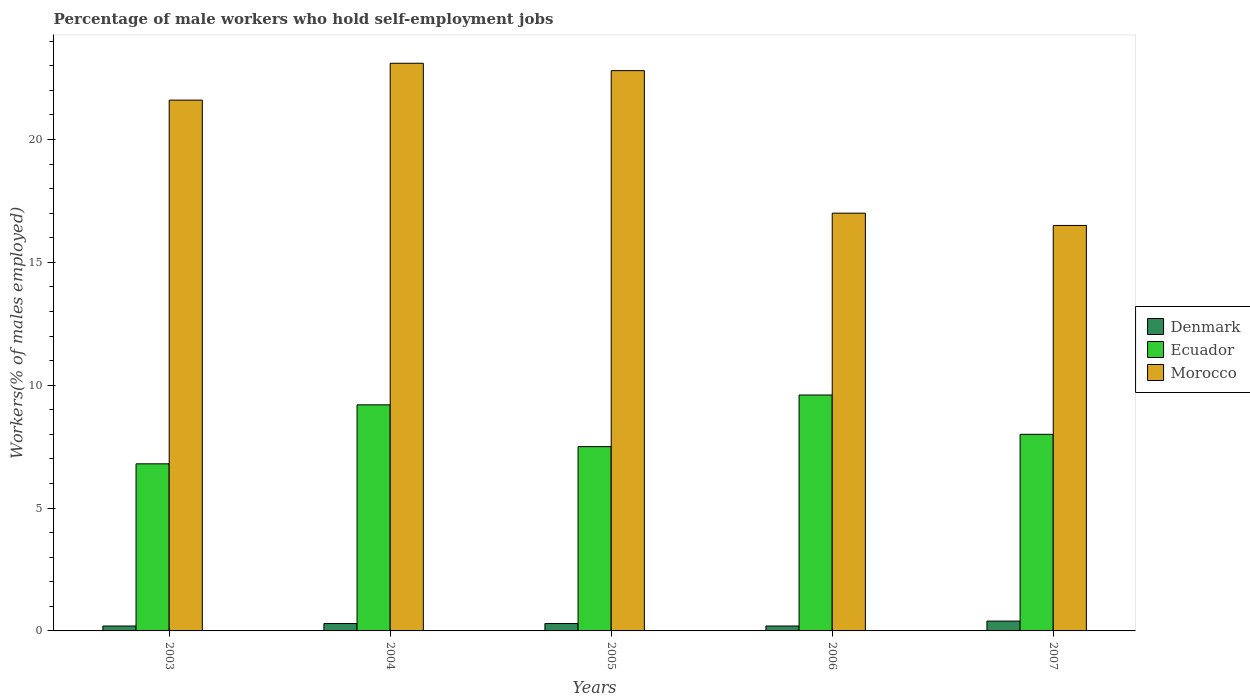Are the number of bars per tick equal to the number of legend labels?
Your answer should be compact. Yes. How many bars are there on the 4th tick from the right?
Make the answer very short. 3. What is the label of the 3rd group of bars from the left?
Offer a terse response. 2005. In how many cases, is the number of bars for a given year not equal to the number of legend labels?
Offer a very short reply. 0. What is the percentage of self-employed male workers in Ecuador in 2004?
Your answer should be compact. 9.2. Across all years, what is the maximum percentage of self-employed male workers in Morocco?
Your answer should be very brief. 23.1. Across all years, what is the minimum percentage of self-employed male workers in Denmark?
Offer a terse response. 0.2. What is the total percentage of self-employed male workers in Ecuador in the graph?
Provide a succinct answer. 41.1. What is the difference between the percentage of self-employed male workers in Ecuador in 2003 and that in 2005?
Make the answer very short. -0.7. What is the difference between the percentage of self-employed male workers in Morocco in 2006 and the percentage of self-employed male workers in Denmark in 2004?
Ensure brevity in your answer.  16.7. What is the average percentage of self-employed male workers in Denmark per year?
Your response must be concise. 0.28. In the year 2005, what is the difference between the percentage of self-employed male workers in Ecuador and percentage of self-employed male workers in Denmark?
Keep it short and to the point. 7.2. What is the ratio of the percentage of self-employed male workers in Morocco in 2003 to that in 2005?
Ensure brevity in your answer.  0.95. Is the percentage of self-employed male workers in Denmark in 2003 less than that in 2004?
Ensure brevity in your answer.  Yes. Is the difference between the percentage of self-employed male workers in Ecuador in 2004 and 2007 greater than the difference between the percentage of self-employed male workers in Denmark in 2004 and 2007?
Offer a very short reply. Yes. What is the difference between the highest and the second highest percentage of self-employed male workers in Ecuador?
Your response must be concise. 0.4. What is the difference between the highest and the lowest percentage of self-employed male workers in Ecuador?
Ensure brevity in your answer.  2.8. In how many years, is the percentage of self-employed male workers in Morocco greater than the average percentage of self-employed male workers in Morocco taken over all years?
Provide a succinct answer. 3. Is the sum of the percentage of self-employed male workers in Ecuador in 2004 and 2006 greater than the maximum percentage of self-employed male workers in Morocco across all years?
Provide a short and direct response. No. What does the 2nd bar from the left in 2006 represents?
Offer a terse response. Ecuador. What does the 1st bar from the right in 2004 represents?
Offer a very short reply. Morocco. How many bars are there?
Provide a short and direct response. 15. What is the difference between two consecutive major ticks on the Y-axis?
Provide a short and direct response. 5. Does the graph contain any zero values?
Make the answer very short. No. Does the graph contain grids?
Your response must be concise. No. What is the title of the graph?
Offer a terse response. Percentage of male workers who hold self-employment jobs. Does "Brunei Darussalam" appear as one of the legend labels in the graph?
Offer a terse response. No. What is the label or title of the X-axis?
Make the answer very short. Years. What is the label or title of the Y-axis?
Offer a terse response. Workers(% of males employed). What is the Workers(% of males employed) in Denmark in 2003?
Your answer should be very brief. 0.2. What is the Workers(% of males employed) in Ecuador in 2003?
Offer a very short reply. 6.8. What is the Workers(% of males employed) of Morocco in 2003?
Make the answer very short. 21.6. What is the Workers(% of males employed) of Denmark in 2004?
Give a very brief answer. 0.3. What is the Workers(% of males employed) in Ecuador in 2004?
Your answer should be compact. 9.2. What is the Workers(% of males employed) in Morocco in 2004?
Give a very brief answer. 23.1. What is the Workers(% of males employed) of Denmark in 2005?
Offer a terse response. 0.3. What is the Workers(% of males employed) in Ecuador in 2005?
Provide a succinct answer. 7.5. What is the Workers(% of males employed) of Morocco in 2005?
Your answer should be very brief. 22.8. What is the Workers(% of males employed) in Denmark in 2006?
Offer a terse response. 0.2. What is the Workers(% of males employed) in Ecuador in 2006?
Ensure brevity in your answer.  9.6. What is the Workers(% of males employed) in Morocco in 2006?
Provide a succinct answer. 17. What is the Workers(% of males employed) of Denmark in 2007?
Provide a succinct answer. 0.4. Across all years, what is the maximum Workers(% of males employed) in Denmark?
Ensure brevity in your answer.  0.4. Across all years, what is the maximum Workers(% of males employed) in Ecuador?
Offer a terse response. 9.6. Across all years, what is the maximum Workers(% of males employed) of Morocco?
Offer a very short reply. 23.1. Across all years, what is the minimum Workers(% of males employed) of Denmark?
Your response must be concise. 0.2. Across all years, what is the minimum Workers(% of males employed) of Ecuador?
Offer a very short reply. 6.8. Across all years, what is the minimum Workers(% of males employed) in Morocco?
Your response must be concise. 16.5. What is the total Workers(% of males employed) of Denmark in the graph?
Your answer should be very brief. 1.4. What is the total Workers(% of males employed) in Ecuador in the graph?
Your response must be concise. 41.1. What is the total Workers(% of males employed) in Morocco in the graph?
Provide a short and direct response. 101. What is the difference between the Workers(% of males employed) of Denmark in 2003 and that in 2004?
Give a very brief answer. -0.1. What is the difference between the Workers(% of males employed) in Denmark in 2003 and that in 2005?
Offer a very short reply. -0.1. What is the difference between the Workers(% of males employed) of Morocco in 2003 and that in 2005?
Your answer should be very brief. -1.2. What is the difference between the Workers(% of males employed) in Denmark in 2003 and that in 2006?
Offer a very short reply. 0. What is the difference between the Workers(% of males employed) in Denmark in 2003 and that in 2007?
Ensure brevity in your answer.  -0.2. What is the difference between the Workers(% of males employed) in Ecuador in 2003 and that in 2007?
Offer a very short reply. -1.2. What is the difference between the Workers(% of males employed) of Ecuador in 2004 and that in 2005?
Give a very brief answer. 1.7. What is the difference between the Workers(% of males employed) of Morocco in 2004 and that in 2005?
Your answer should be very brief. 0.3. What is the difference between the Workers(% of males employed) of Ecuador in 2004 and that in 2006?
Offer a very short reply. -0.4. What is the difference between the Workers(% of males employed) in Morocco in 2004 and that in 2006?
Offer a terse response. 6.1. What is the difference between the Workers(% of males employed) in Ecuador in 2004 and that in 2007?
Offer a very short reply. 1.2. What is the difference between the Workers(% of males employed) in Morocco in 2004 and that in 2007?
Offer a very short reply. 6.6. What is the difference between the Workers(% of males employed) in Denmark in 2005 and that in 2006?
Keep it short and to the point. 0.1. What is the difference between the Workers(% of males employed) of Morocco in 2005 and that in 2006?
Make the answer very short. 5.8. What is the difference between the Workers(% of males employed) of Morocco in 2005 and that in 2007?
Offer a terse response. 6.3. What is the difference between the Workers(% of males employed) in Denmark in 2003 and the Workers(% of males employed) in Morocco in 2004?
Your answer should be very brief. -22.9. What is the difference between the Workers(% of males employed) of Ecuador in 2003 and the Workers(% of males employed) of Morocco in 2004?
Your answer should be very brief. -16.3. What is the difference between the Workers(% of males employed) in Denmark in 2003 and the Workers(% of males employed) in Ecuador in 2005?
Ensure brevity in your answer.  -7.3. What is the difference between the Workers(% of males employed) of Denmark in 2003 and the Workers(% of males employed) of Morocco in 2005?
Provide a short and direct response. -22.6. What is the difference between the Workers(% of males employed) of Ecuador in 2003 and the Workers(% of males employed) of Morocco in 2005?
Keep it short and to the point. -16. What is the difference between the Workers(% of males employed) in Denmark in 2003 and the Workers(% of males employed) in Ecuador in 2006?
Your response must be concise. -9.4. What is the difference between the Workers(% of males employed) of Denmark in 2003 and the Workers(% of males employed) of Morocco in 2006?
Ensure brevity in your answer.  -16.8. What is the difference between the Workers(% of males employed) of Ecuador in 2003 and the Workers(% of males employed) of Morocco in 2006?
Provide a short and direct response. -10.2. What is the difference between the Workers(% of males employed) of Denmark in 2003 and the Workers(% of males employed) of Ecuador in 2007?
Offer a terse response. -7.8. What is the difference between the Workers(% of males employed) in Denmark in 2003 and the Workers(% of males employed) in Morocco in 2007?
Provide a short and direct response. -16.3. What is the difference between the Workers(% of males employed) of Denmark in 2004 and the Workers(% of males employed) of Ecuador in 2005?
Your response must be concise. -7.2. What is the difference between the Workers(% of males employed) in Denmark in 2004 and the Workers(% of males employed) in Morocco in 2005?
Provide a succinct answer. -22.5. What is the difference between the Workers(% of males employed) of Ecuador in 2004 and the Workers(% of males employed) of Morocco in 2005?
Give a very brief answer. -13.6. What is the difference between the Workers(% of males employed) of Denmark in 2004 and the Workers(% of males employed) of Ecuador in 2006?
Your response must be concise. -9.3. What is the difference between the Workers(% of males employed) in Denmark in 2004 and the Workers(% of males employed) in Morocco in 2006?
Your response must be concise. -16.7. What is the difference between the Workers(% of males employed) in Ecuador in 2004 and the Workers(% of males employed) in Morocco in 2006?
Offer a terse response. -7.8. What is the difference between the Workers(% of males employed) in Denmark in 2004 and the Workers(% of males employed) in Morocco in 2007?
Your response must be concise. -16.2. What is the difference between the Workers(% of males employed) of Denmark in 2005 and the Workers(% of males employed) of Ecuador in 2006?
Keep it short and to the point. -9.3. What is the difference between the Workers(% of males employed) in Denmark in 2005 and the Workers(% of males employed) in Morocco in 2006?
Provide a short and direct response. -16.7. What is the difference between the Workers(% of males employed) in Denmark in 2005 and the Workers(% of males employed) in Morocco in 2007?
Your answer should be compact. -16.2. What is the difference between the Workers(% of males employed) in Denmark in 2006 and the Workers(% of males employed) in Ecuador in 2007?
Keep it short and to the point. -7.8. What is the difference between the Workers(% of males employed) in Denmark in 2006 and the Workers(% of males employed) in Morocco in 2007?
Offer a very short reply. -16.3. What is the difference between the Workers(% of males employed) in Ecuador in 2006 and the Workers(% of males employed) in Morocco in 2007?
Your answer should be very brief. -6.9. What is the average Workers(% of males employed) of Denmark per year?
Offer a very short reply. 0.28. What is the average Workers(% of males employed) of Ecuador per year?
Provide a succinct answer. 8.22. What is the average Workers(% of males employed) of Morocco per year?
Make the answer very short. 20.2. In the year 2003, what is the difference between the Workers(% of males employed) of Denmark and Workers(% of males employed) of Morocco?
Provide a succinct answer. -21.4. In the year 2003, what is the difference between the Workers(% of males employed) in Ecuador and Workers(% of males employed) in Morocco?
Offer a terse response. -14.8. In the year 2004, what is the difference between the Workers(% of males employed) in Denmark and Workers(% of males employed) in Morocco?
Give a very brief answer. -22.8. In the year 2004, what is the difference between the Workers(% of males employed) of Ecuador and Workers(% of males employed) of Morocco?
Offer a very short reply. -13.9. In the year 2005, what is the difference between the Workers(% of males employed) in Denmark and Workers(% of males employed) in Ecuador?
Provide a succinct answer. -7.2. In the year 2005, what is the difference between the Workers(% of males employed) in Denmark and Workers(% of males employed) in Morocco?
Give a very brief answer. -22.5. In the year 2005, what is the difference between the Workers(% of males employed) of Ecuador and Workers(% of males employed) of Morocco?
Keep it short and to the point. -15.3. In the year 2006, what is the difference between the Workers(% of males employed) of Denmark and Workers(% of males employed) of Ecuador?
Give a very brief answer. -9.4. In the year 2006, what is the difference between the Workers(% of males employed) of Denmark and Workers(% of males employed) of Morocco?
Your answer should be very brief. -16.8. In the year 2006, what is the difference between the Workers(% of males employed) of Ecuador and Workers(% of males employed) of Morocco?
Make the answer very short. -7.4. In the year 2007, what is the difference between the Workers(% of males employed) of Denmark and Workers(% of males employed) of Ecuador?
Provide a succinct answer. -7.6. In the year 2007, what is the difference between the Workers(% of males employed) of Denmark and Workers(% of males employed) of Morocco?
Provide a short and direct response. -16.1. What is the ratio of the Workers(% of males employed) in Denmark in 2003 to that in 2004?
Give a very brief answer. 0.67. What is the ratio of the Workers(% of males employed) in Ecuador in 2003 to that in 2004?
Provide a succinct answer. 0.74. What is the ratio of the Workers(% of males employed) in Morocco in 2003 to that in 2004?
Keep it short and to the point. 0.94. What is the ratio of the Workers(% of males employed) of Denmark in 2003 to that in 2005?
Ensure brevity in your answer.  0.67. What is the ratio of the Workers(% of males employed) in Ecuador in 2003 to that in 2005?
Your response must be concise. 0.91. What is the ratio of the Workers(% of males employed) of Ecuador in 2003 to that in 2006?
Your answer should be compact. 0.71. What is the ratio of the Workers(% of males employed) in Morocco in 2003 to that in 2006?
Provide a succinct answer. 1.27. What is the ratio of the Workers(% of males employed) of Denmark in 2003 to that in 2007?
Keep it short and to the point. 0.5. What is the ratio of the Workers(% of males employed) in Morocco in 2003 to that in 2007?
Offer a terse response. 1.31. What is the ratio of the Workers(% of males employed) in Ecuador in 2004 to that in 2005?
Provide a succinct answer. 1.23. What is the ratio of the Workers(% of males employed) in Morocco in 2004 to that in 2005?
Your answer should be compact. 1.01. What is the ratio of the Workers(% of males employed) of Morocco in 2004 to that in 2006?
Your answer should be very brief. 1.36. What is the ratio of the Workers(% of males employed) in Ecuador in 2004 to that in 2007?
Give a very brief answer. 1.15. What is the ratio of the Workers(% of males employed) in Morocco in 2004 to that in 2007?
Provide a succinct answer. 1.4. What is the ratio of the Workers(% of males employed) of Denmark in 2005 to that in 2006?
Provide a short and direct response. 1.5. What is the ratio of the Workers(% of males employed) in Ecuador in 2005 to that in 2006?
Ensure brevity in your answer.  0.78. What is the ratio of the Workers(% of males employed) of Morocco in 2005 to that in 2006?
Your answer should be very brief. 1.34. What is the ratio of the Workers(% of males employed) in Morocco in 2005 to that in 2007?
Provide a succinct answer. 1.38. What is the ratio of the Workers(% of males employed) in Morocco in 2006 to that in 2007?
Your answer should be compact. 1.03. What is the difference between the highest and the second highest Workers(% of males employed) in Denmark?
Your answer should be compact. 0.1. What is the difference between the highest and the second highest Workers(% of males employed) of Ecuador?
Provide a short and direct response. 0.4. What is the difference between the highest and the lowest Workers(% of males employed) of Morocco?
Keep it short and to the point. 6.6. 